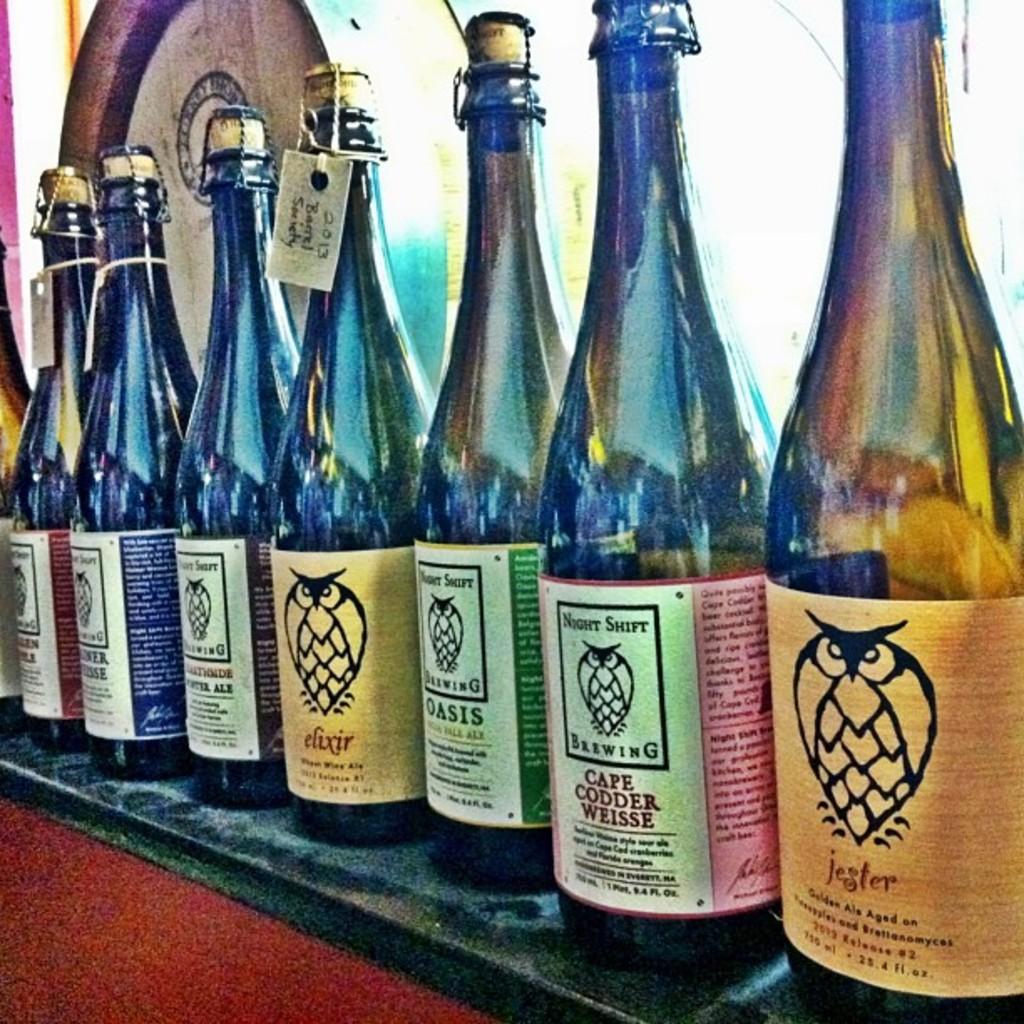What company makes this drink?
Provide a short and direct response. Night shift brewing. 